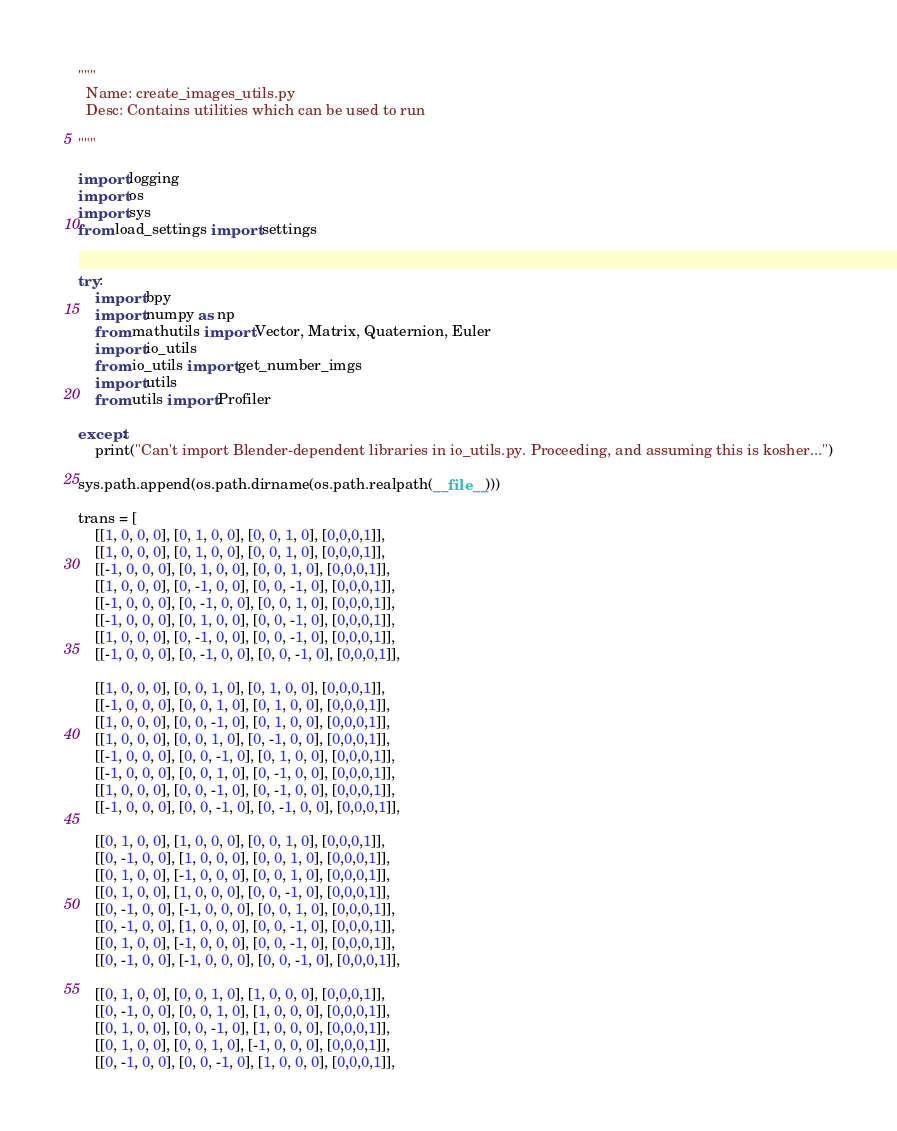<code> <loc_0><loc_0><loc_500><loc_500><_Python_>"""
  Name: create_images_utils.py
  Desc: Contains utilities which can be used to run 
  
"""

import logging
import os
import sys
from load_settings import settings


try:
    import bpy
    import numpy as np
    from mathutils import Vector, Matrix, Quaternion, Euler
    import io_utils
    from io_utils import get_number_imgs
    import utils
    from utils import Profiler

except:
    print("Can't import Blender-dependent libraries in io_utils.py. Proceeding, and assuming this is kosher...")

sys.path.append(os.path.dirname(os.path.realpath(__file__)))

trans = [
    [[1, 0, 0, 0], [0, 1, 0, 0], [0, 0, 1, 0], [0,0,0,1]],
    [[1, 0, 0, 0], [0, 1, 0, 0], [0, 0, 1, 0], [0,0,0,1]],
    [[-1, 0, 0, 0], [0, 1, 0, 0], [0, 0, 1, 0], [0,0,0,1]],
    [[1, 0, 0, 0], [0, -1, 0, 0], [0, 0, -1, 0], [0,0,0,1]],
    [[-1, 0, 0, 0], [0, -1, 0, 0], [0, 0, 1, 0], [0,0,0,1]],
    [[-1, 0, 0, 0], [0, 1, 0, 0], [0, 0, -1, 0], [0,0,0,1]],
    [[1, 0, 0, 0], [0, -1, 0, 0], [0, 0, -1, 0], [0,0,0,1]],
    [[-1, 0, 0, 0], [0, -1, 0, 0], [0, 0, -1, 0], [0,0,0,1]],

    [[1, 0, 0, 0], [0, 0, 1, 0], [0, 1, 0, 0], [0,0,0,1]],
    [[-1, 0, 0, 0], [0, 0, 1, 0], [0, 1, 0, 0], [0,0,0,1]],
    [[1, 0, 0, 0], [0, 0, -1, 0], [0, 1, 0, 0], [0,0,0,1]],
    [[1, 0, 0, 0], [0, 0, 1, 0], [0, -1, 0, 0], [0,0,0,1]],
    [[-1, 0, 0, 0], [0, 0, -1, 0], [0, 1, 0, 0], [0,0,0,1]],
    [[-1, 0, 0, 0], [0, 0, 1, 0], [0, -1, 0, 0], [0,0,0,1]],
    [[1, 0, 0, 0], [0, 0, -1, 0], [0, -1, 0, 0], [0,0,0,1]],
    [[-1, 0, 0, 0], [0, 0, -1, 0], [0, -1, 0, 0], [0,0,0,1]],

    [[0, 1, 0, 0], [1, 0, 0, 0], [0, 0, 1, 0], [0,0,0,1]],
    [[0, -1, 0, 0], [1, 0, 0, 0], [0, 0, 1, 0], [0,0,0,1]],
    [[0, 1, 0, 0], [-1, 0, 0, 0], [0, 0, 1, 0], [0,0,0,1]],
    [[0, 1, 0, 0], [1, 0, 0, 0], [0, 0, -1, 0], [0,0,0,1]],
    [[0, -1, 0, 0], [-1, 0, 0, 0], [0, 0, 1, 0], [0,0,0,1]],
    [[0, -1, 0, 0], [1, 0, 0, 0], [0, 0, -1, 0], [0,0,0,1]],
    [[0, 1, 0, 0], [-1, 0, 0, 0], [0, 0, -1, 0], [0,0,0,1]],
    [[0, -1, 0, 0], [-1, 0, 0, 0], [0, 0, -1, 0], [0,0,0,1]],

    [[0, 1, 0, 0], [0, 0, 1, 0], [1, 0, 0, 0], [0,0,0,1]],
    [[0, -1, 0, 0], [0, 0, 1, 0], [1, 0, 0, 0], [0,0,0,1]],
    [[0, 1, 0, 0], [0, 0, -1, 0], [1, 0, 0, 0], [0,0,0,1]],
    [[0, 1, 0, 0], [0, 0, 1, 0], [-1, 0, 0, 0], [0,0,0,1]],
    [[0, -1, 0, 0], [0, 0, -1, 0], [1, 0, 0, 0], [0,0,0,1]],</code> 